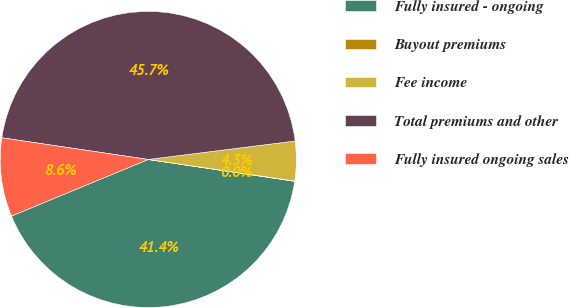Convert chart. <chart><loc_0><loc_0><loc_500><loc_500><pie_chart><fcel>Fully insured - ongoing<fcel>Buyout premiums<fcel>Fee income<fcel>Total premiums and other<fcel>Fully insured ongoing sales<nl><fcel>41.4%<fcel>0.04%<fcel>4.31%<fcel>45.67%<fcel>8.58%<nl></chart> 